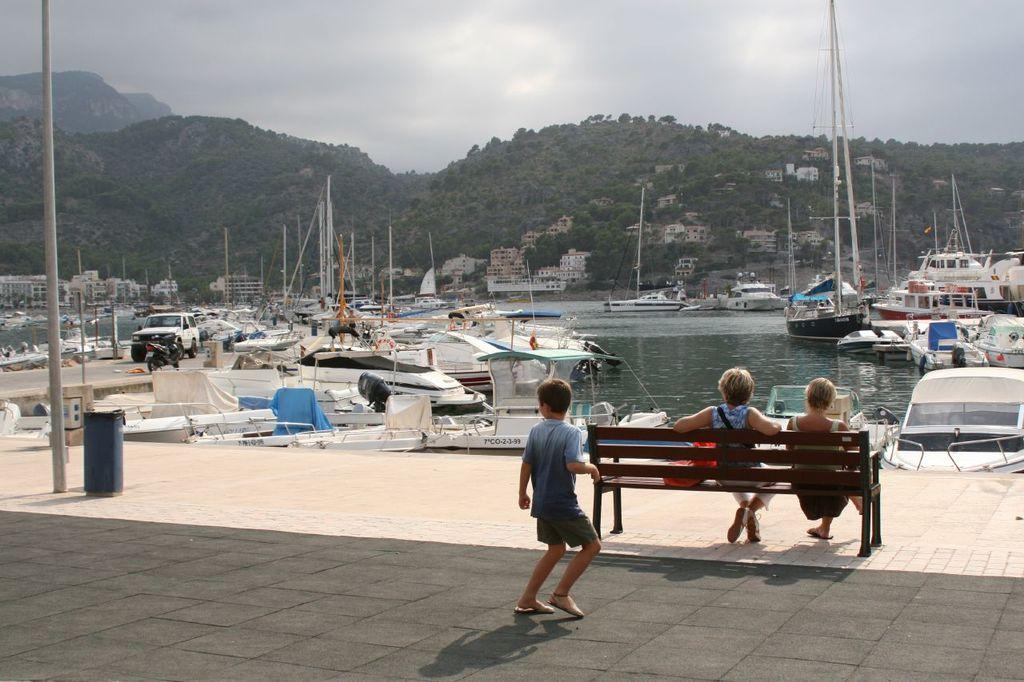What types of watercraft are visible in the image? There are boats and ships on the water in the image. How many people are present in the image? There are three persons in the image. What other types of transportation can be seen in the image? There are vehicles in the image. What type of landscape feature is visible in the image? There are hills in the image. What type of seating is present in the image? There is a bench in the image. What is visible in the background of the image? The sky is visible in the background of the image. What type of recess is available for the boats and ships in the image? There is no recess for the boats and ships in the image; they are on the water. What type of brake system is present on the hills in the image? There are no brake systems present on the hills in the image; they are a natural landscape feature. 